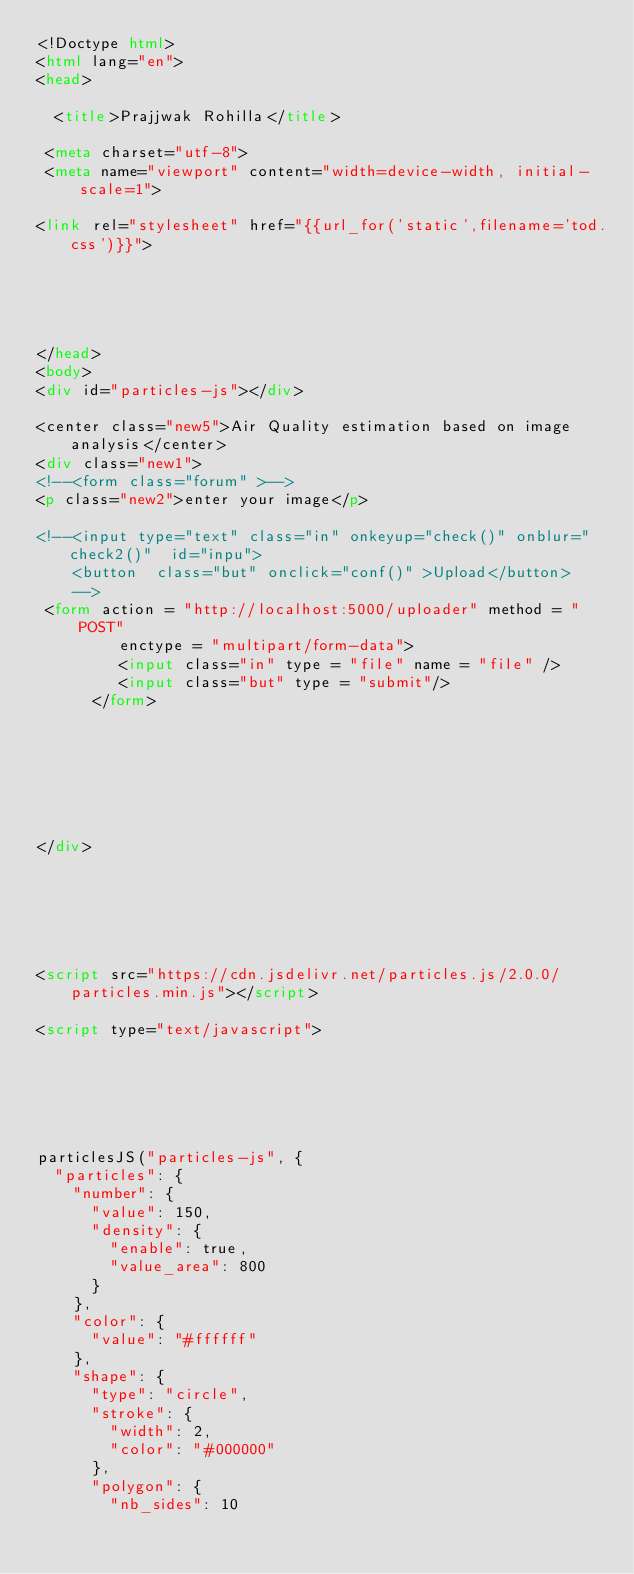<code> <loc_0><loc_0><loc_500><loc_500><_HTML_><!Doctype html>
<html lang="en">
<head>

  <title>Prajjwak Rohilla</title>

 <meta charset="utf-8"> 
 <meta name="viewport" content="width=device-width, initial-scale=1">

<link rel="stylesheet" href="{{url_for('static',filename='tod.css')}}">





</head>
<body>
<div id="particles-js"></div>

<center class="new5">Air Quality estimation based on image analysis</center>
<div class="new1">
<!--<form class="forum" >-->
<p class="new2">enter your image</p>
    
<!--<input type="text" class="in" onkeyup="check()" onblur="check2()"  id="inpu">
    <button  class="but" onclick="conf()" >Upload</button>
    -->
 <form action = "http://localhost:5000/uploader" method = "POST" 
         enctype = "multipart/form-data">
         <input class="in" type = "file" name = "file" />
         <input class="but" type = "submit"/>
      </form>
    
   
    
    
    
    
    
</div>






<script src="https://cdn.jsdelivr.net/particles.js/2.0.0/particles.min.js"></script>

<script type="text/javascript">

    
   
 
    

particlesJS("particles-js", {
  "particles": {
    "number": {
      "value": 150,
      "density": {
        "enable": true,
        "value_area": 800
      }
    },
    "color": {
      "value": "#ffffff"
    },
    "shape": {
      "type": "circle",
      "stroke": {
        "width": 2,
        "color": "#000000"
      },
      "polygon": {
        "nb_sides": 10</code> 